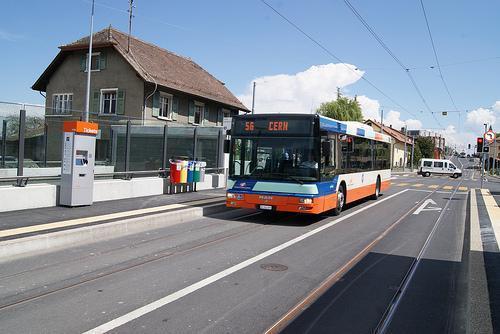How many buses are shown?
Give a very brief answer. 1. How many vehicles in total are shown?
Give a very brief answer. 2. 